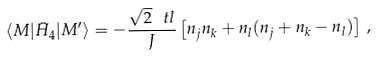Convert formula to latex. <formula><loc_0><loc_0><loc_500><loc_500>\langle M | \bar { H } _ { 4 } | M ^ { \prime } \rangle = - \frac { \sqrt { 2 } \, \ t l } { J } \left [ n _ { j } n _ { k } + n _ { l } ( n _ { j } + n _ { k } - n _ { l } ) \right ] \, ,</formula> 